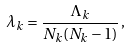Convert formula to latex. <formula><loc_0><loc_0><loc_500><loc_500>\lambda _ { k } = \frac { \Lambda _ { k } } { N _ { k } ( N _ { k } - 1 ) } \, ,</formula> 